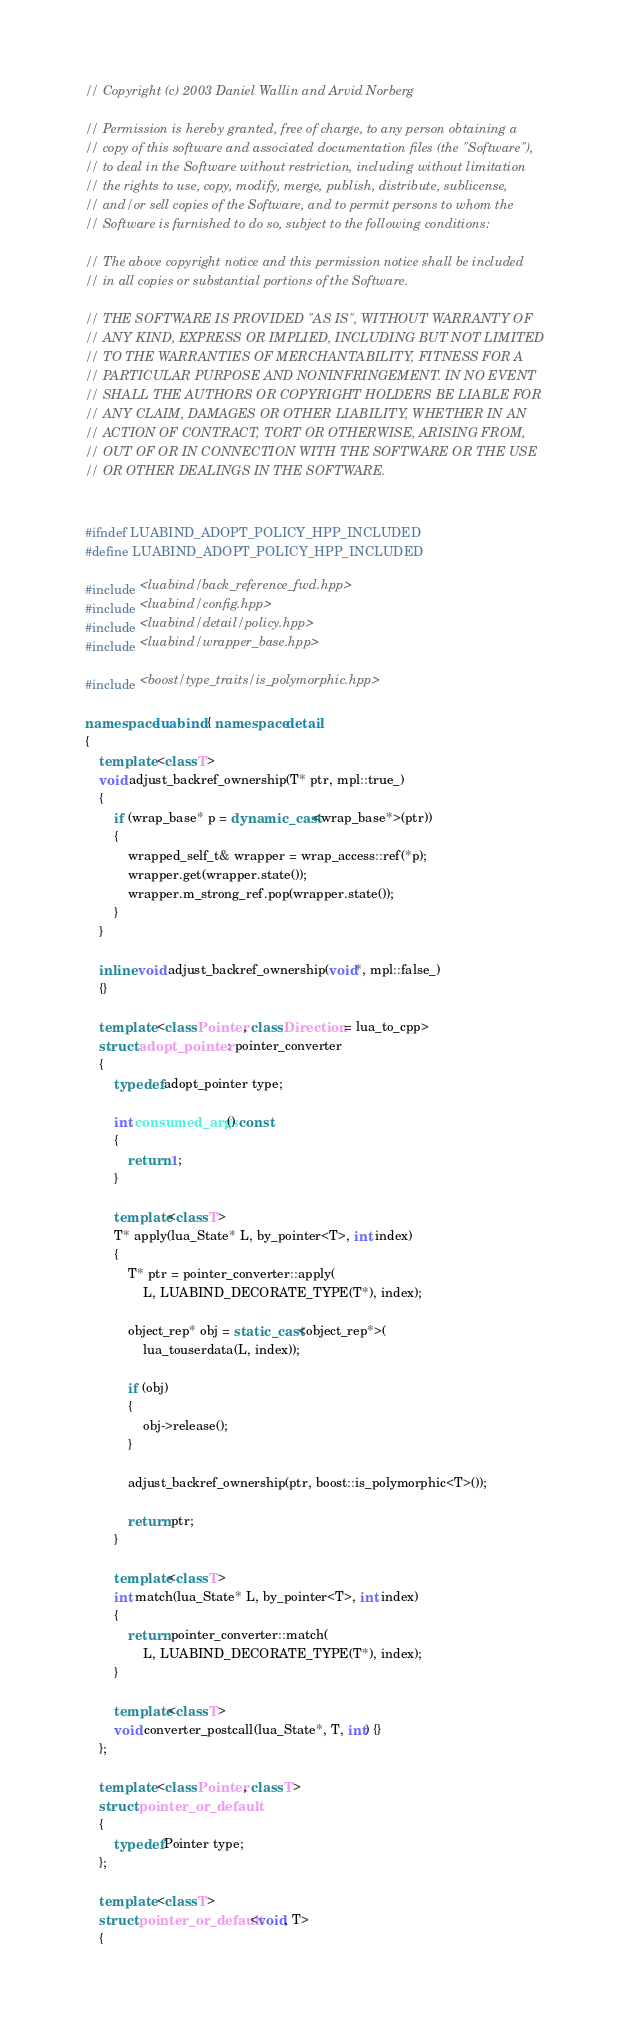<code> <loc_0><loc_0><loc_500><loc_500><_C++_>// Copyright (c) 2003 Daniel Wallin and Arvid Norberg

// Permission is hereby granted, free of charge, to any person obtaining a
// copy of this software and associated documentation files (the "Software"),
// to deal in the Software without restriction, including without limitation
// the rights to use, copy, modify, merge, publish, distribute, sublicense,
// and/or sell copies of the Software, and to permit persons to whom the
// Software is furnished to do so, subject to the following conditions:

// The above copyright notice and this permission notice shall be included
// in all copies or substantial portions of the Software.

// THE SOFTWARE IS PROVIDED "AS IS", WITHOUT WARRANTY OF
// ANY KIND, EXPRESS OR IMPLIED, INCLUDING BUT NOT LIMITED
// TO THE WARRANTIES OF MERCHANTABILITY, FITNESS FOR A
// PARTICULAR PURPOSE AND NONINFRINGEMENT. IN NO EVENT
// SHALL THE AUTHORS OR COPYRIGHT HOLDERS BE LIABLE FOR
// ANY CLAIM, DAMAGES OR OTHER LIABILITY, WHETHER IN AN
// ACTION OF CONTRACT, TORT OR OTHERWISE, ARISING FROM,
// OUT OF OR IN CONNECTION WITH THE SOFTWARE OR THE USE
// OR OTHER DEALINGS IN THE SOFTWARE.


#ifndef LUABIND_ADOPT_POLICY_HPP_INCLUDED
#define LUABIND_ADOPT_POLICY_HPP_INCLUDED

#include <luabind/back_reference_fwd.hpp>
#include <luabind/config.hpp>
#include <luabind/detail/policy.hpp>
#include <luabind/wrapper_base.hpp>

#include <boost/type_traits/is_polymorphic.hpp>

namespace luabind { namespace detail
{
    template <class T>
    void adjust_backref_ownership(T* ptr, mpl::true_)
    {
        if (wrap_base* p = dynamic_cast<wrap_base*>(ptr))
        {
            wrapped_self_t& wrapper = wrap_access::ref(*p);
            wrapper.get(wrapper.state());
            wrapper.m_strong_ref.pop(wrapper.state());
        }
    }

    inline void adjust_backref_ownership(void*, mpl::false_)
    {}

    template <class Pointer, class Direction = lua_to_cpp>
    struct adopt_pointer : pointer_converter
    {
        typedef adopt_pointer type;

        int consumed_args() const
        {
            return 1;
        }

        template<class T>
        T* apply(lua_State* L, by_pointer<T>, int index)
        {
            T* ptr = pointer_converter::apply(
                L, LUABIND_DECORATE_TYPE(T*), index);

            object_rep* obj = static_cast<object_rep*>(
                lua_touserdata(L, index));

            if (obj)
            {
                obj->release();
            }

            adjust_backref_ownership(ptr, boost::is_polymorphic<T>());

            return ptr;
        }

        template<class T>
        int match(lua_State* L, by_pointer<T>, int index)
        {
            return pointer_converter::match(
                L, LUABIND_DECORATE_TYPE(T*), index);
        }

        template<class T>
        void converter_postcall(lua_State*, T, int) {}
    };

    template <class Pointer, class T>
    struct pointer_or_default
    {
        typedef Pointer type;
    };

    template <class T>
    struct pointer_or_default<void, T>
    {</code> 